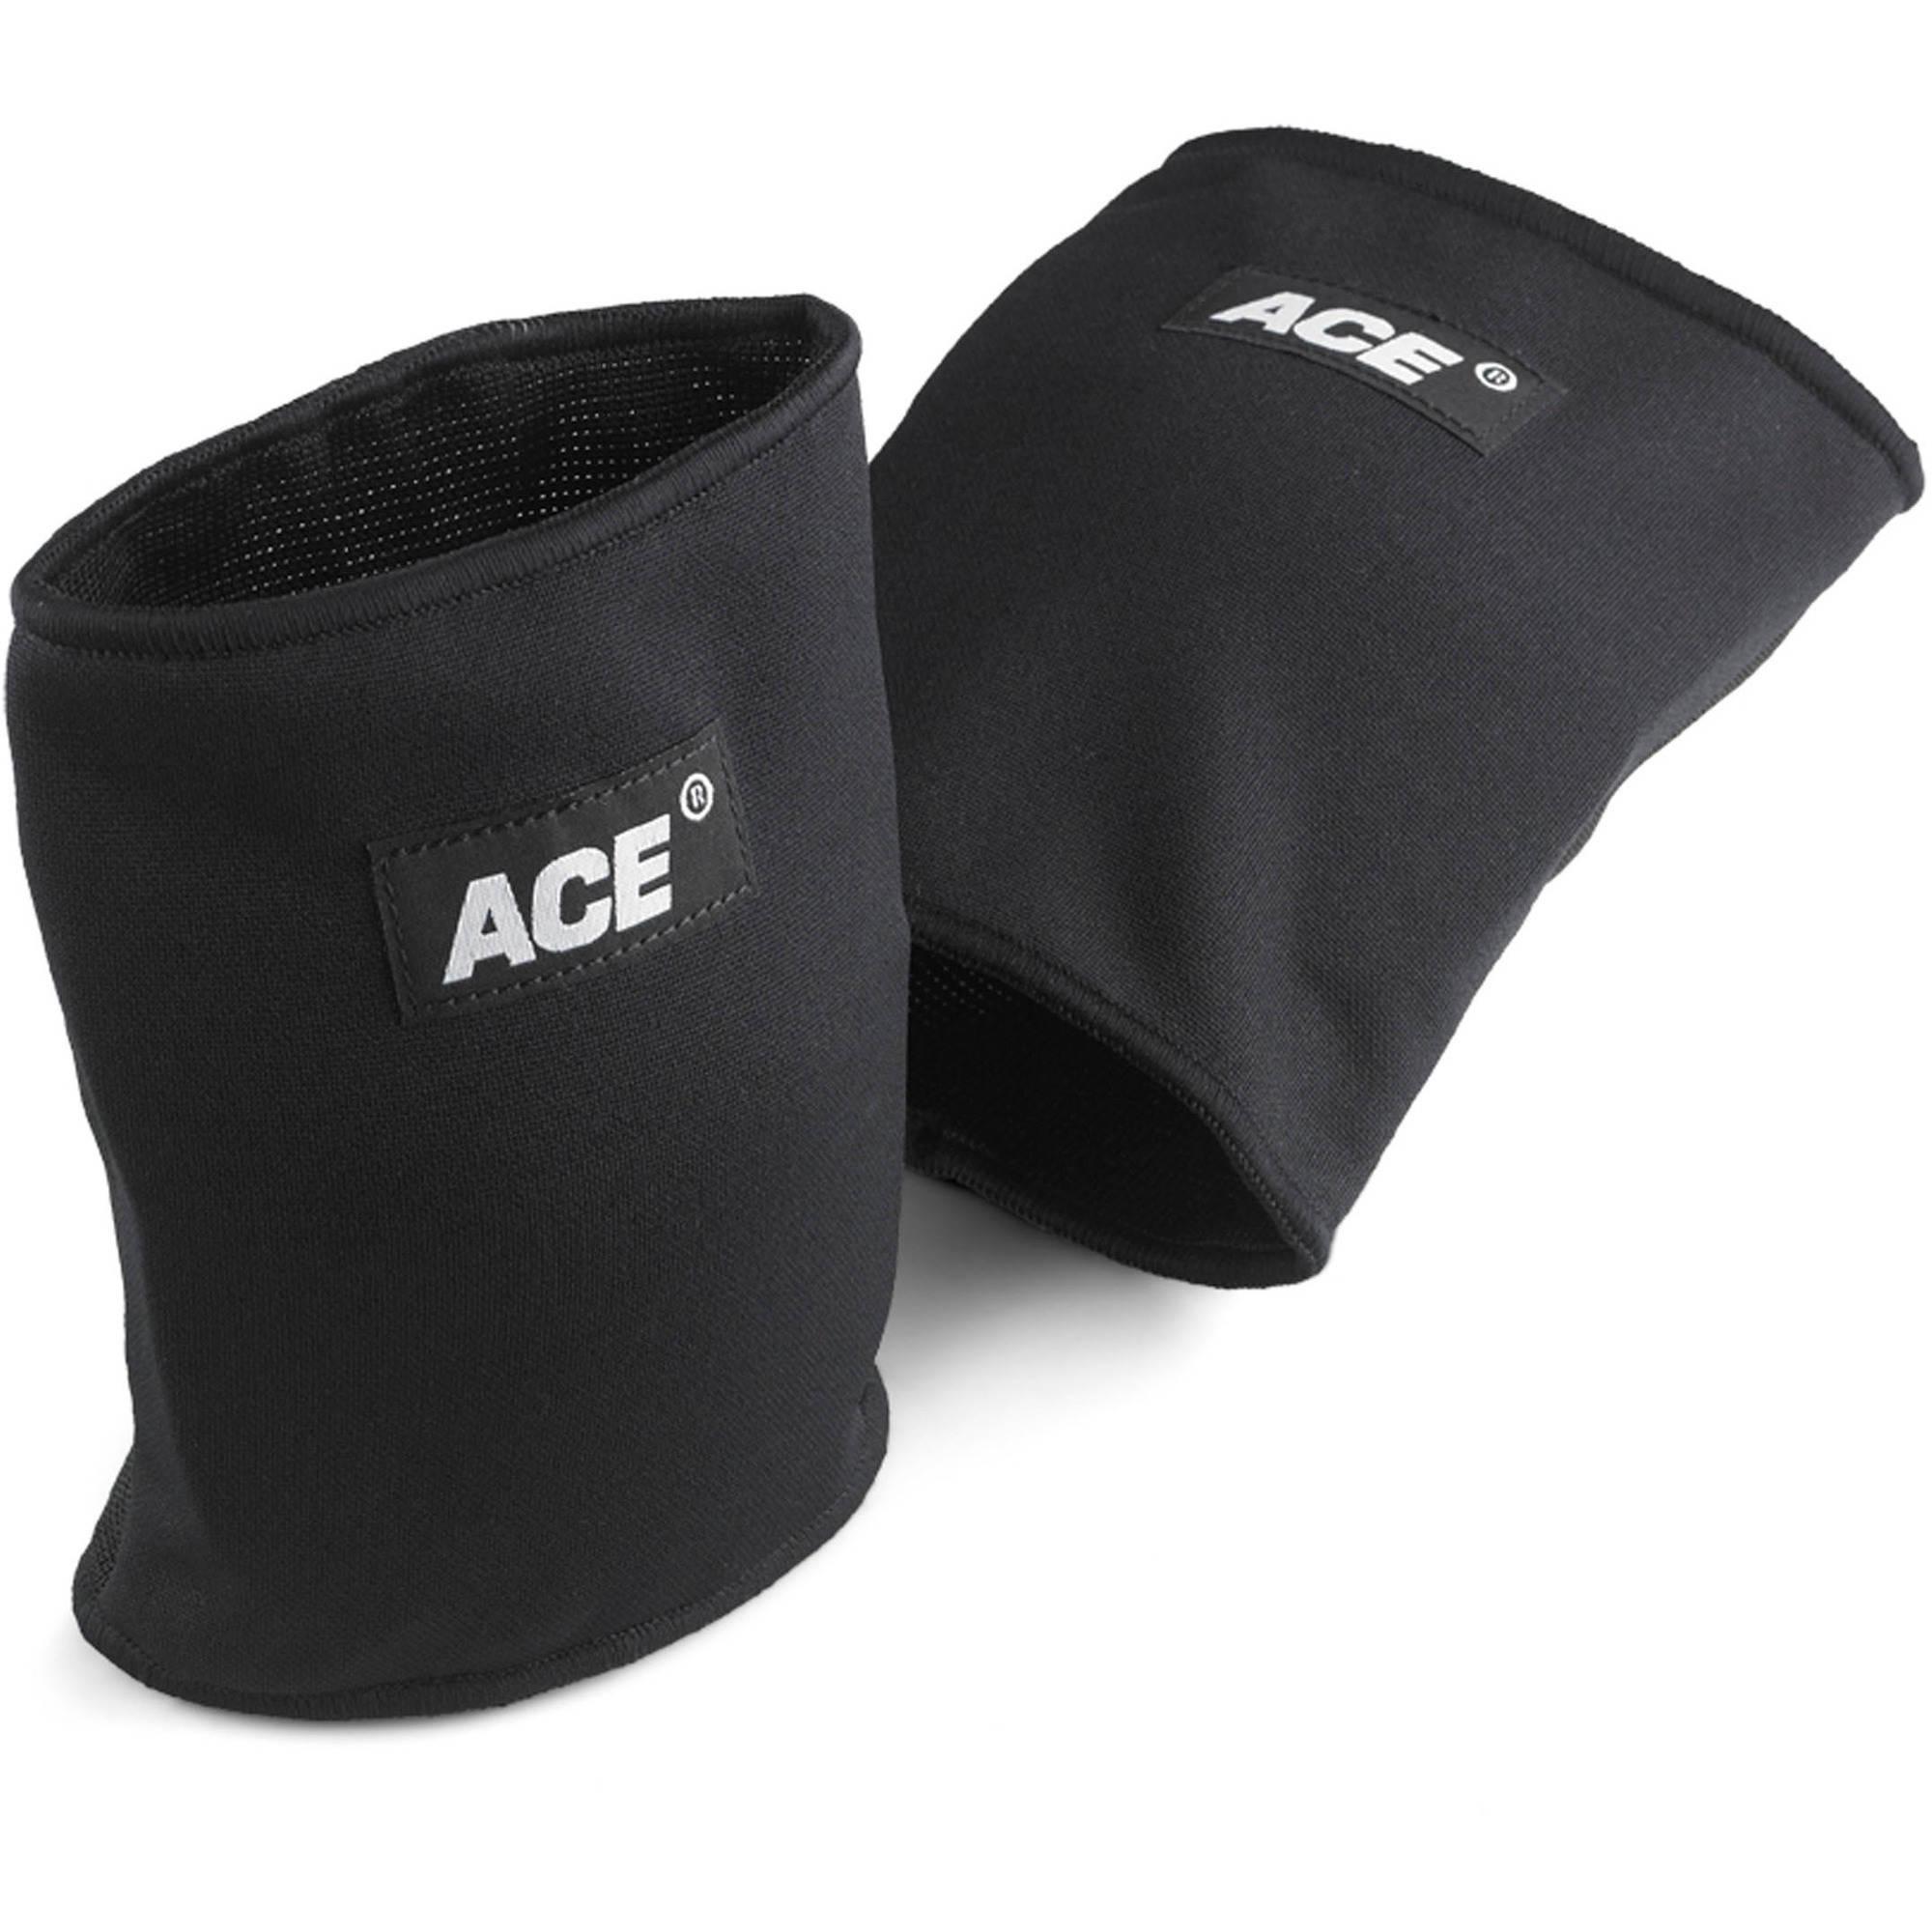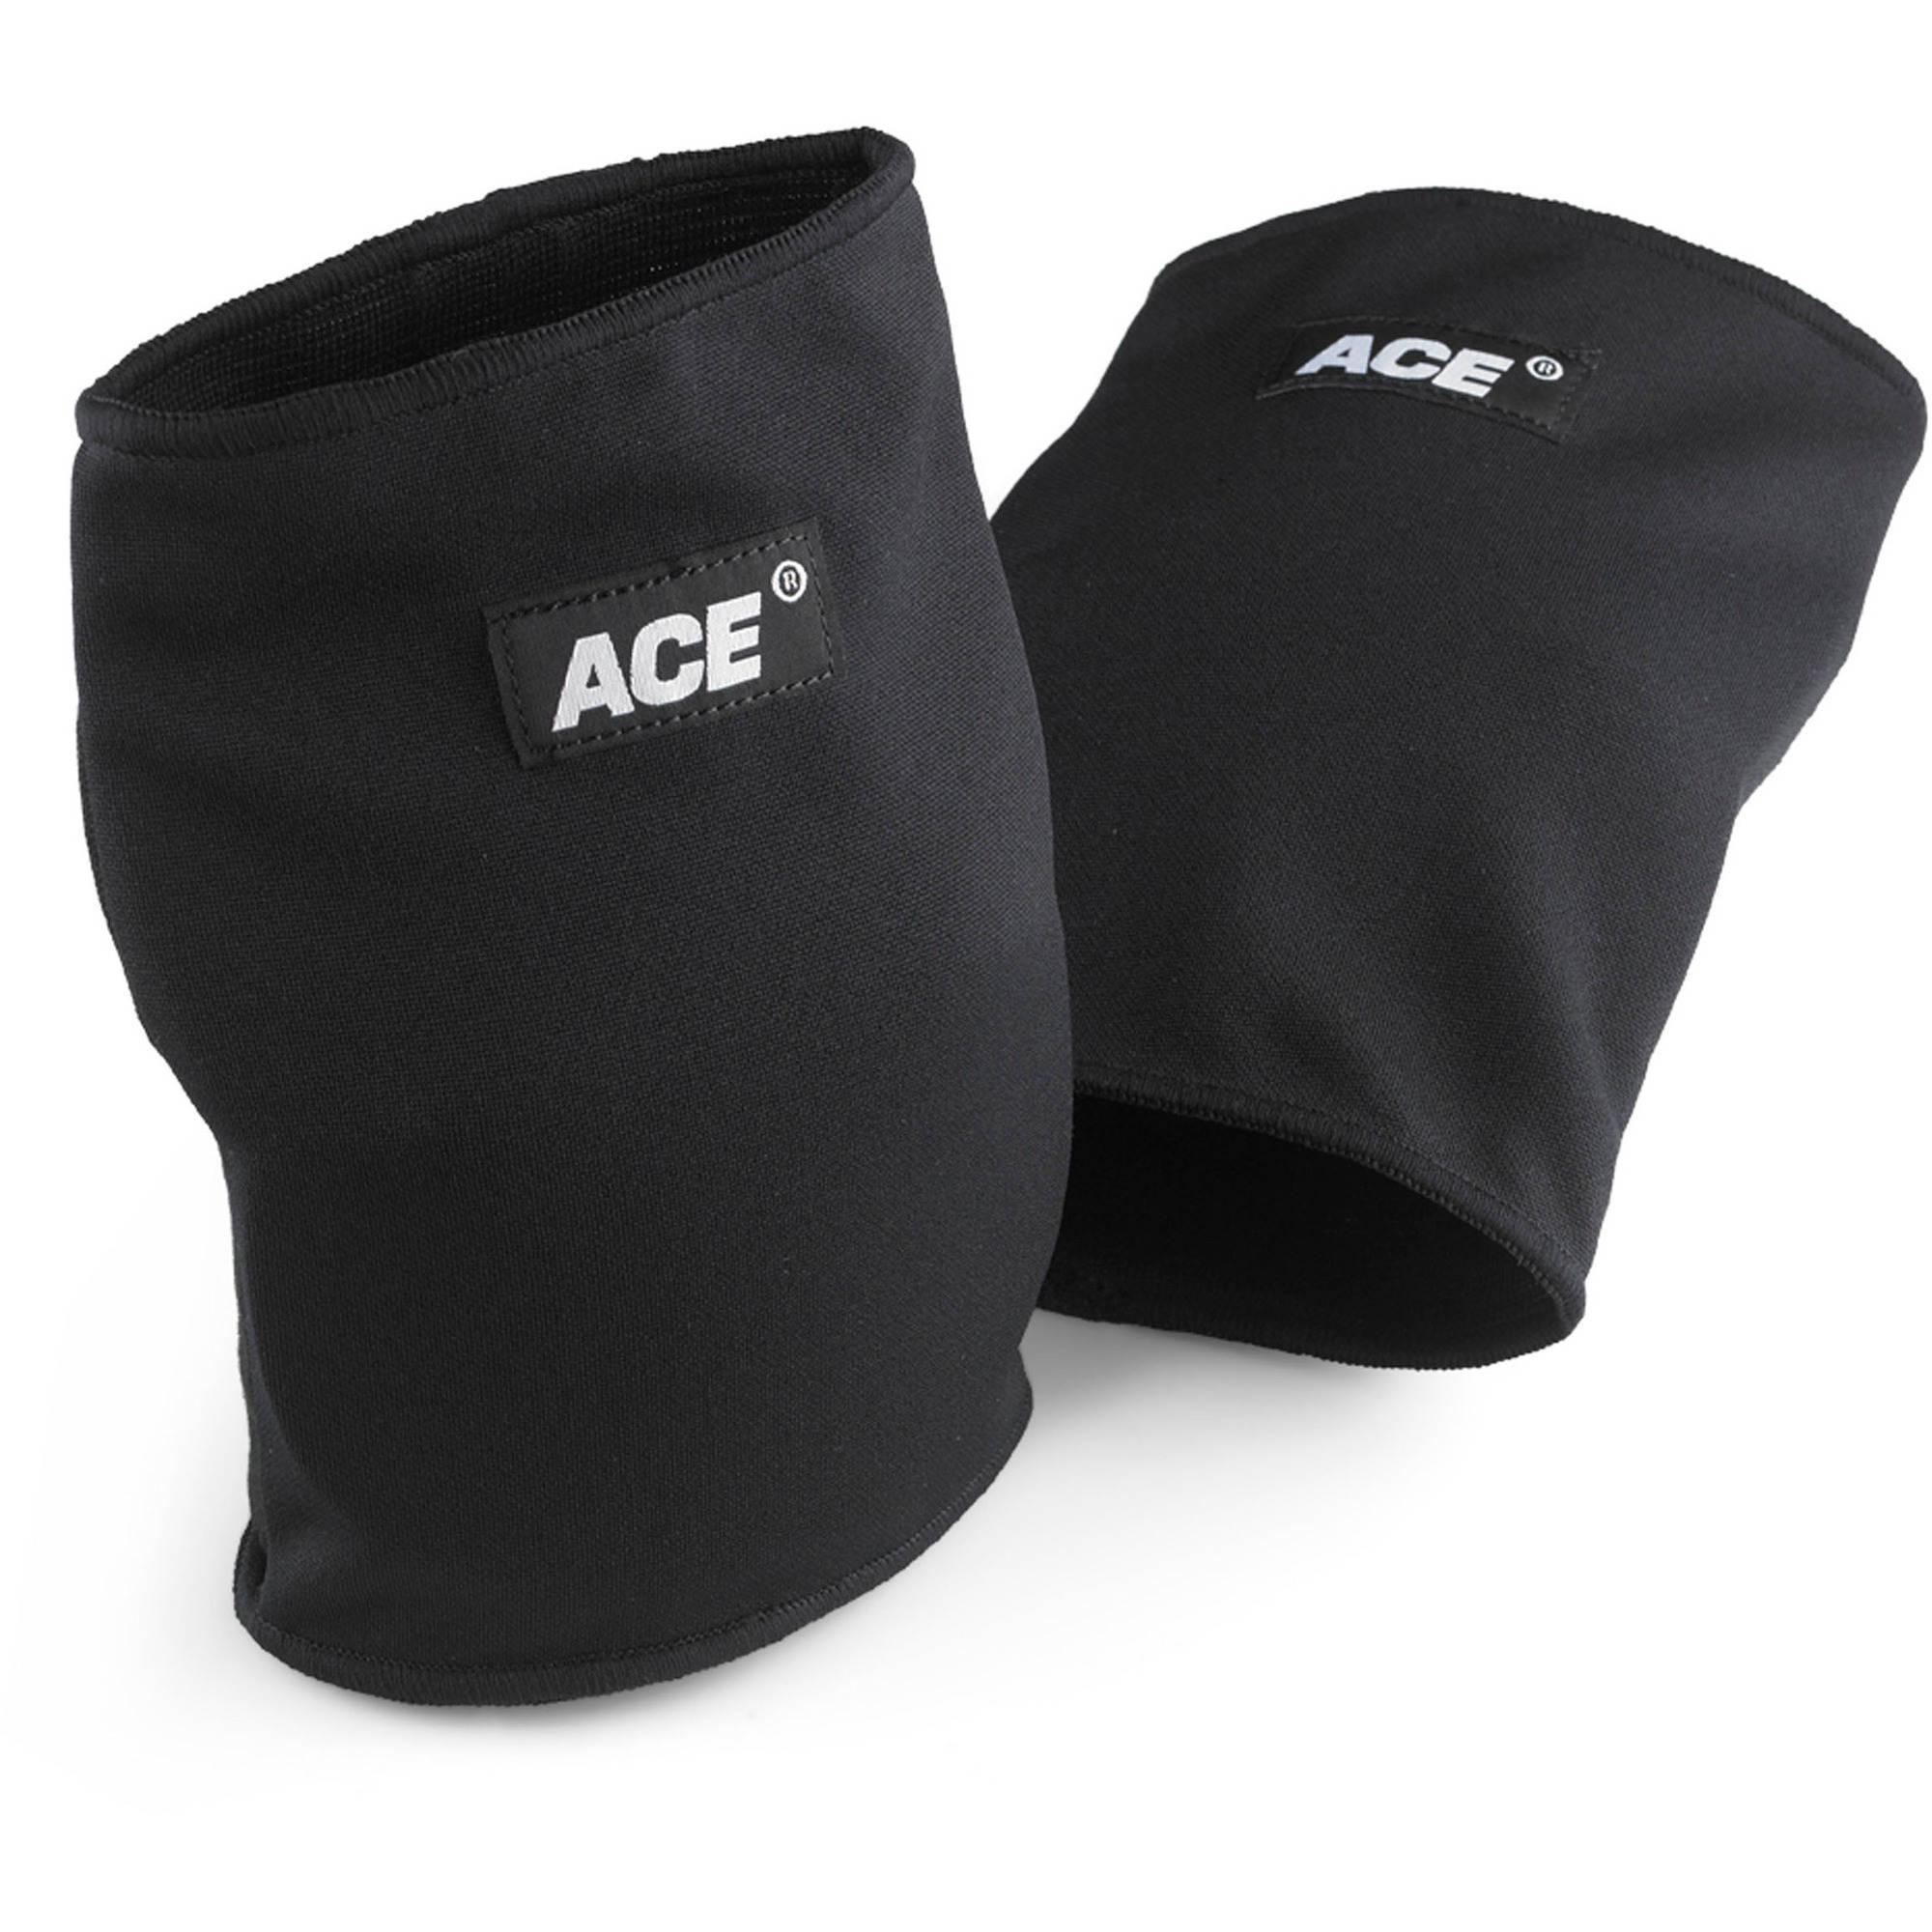The first image is the image on the left, the second image is the image on the right. Analyze the images presented: Is the assertion "One image shows the knee brace package." valid? Answer yes or no. No. 